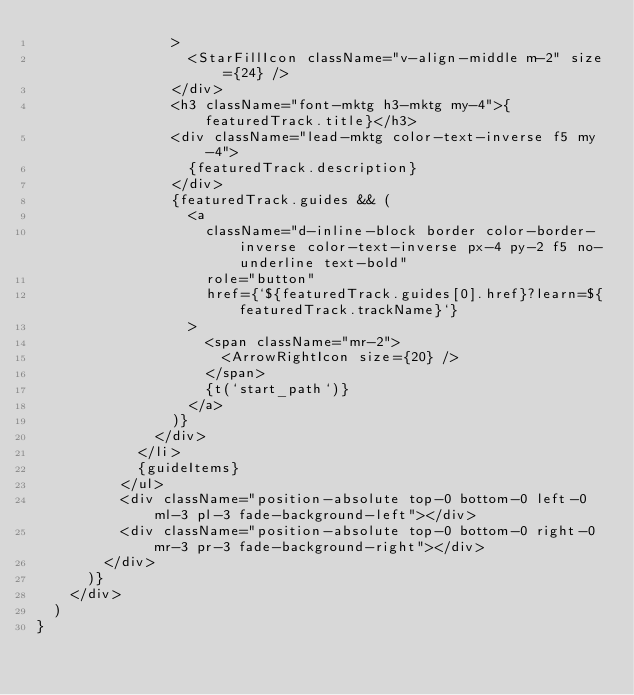<code> <loc_0><loc_0><loc_500><loc_500><_TypeScript_>                >
                  <StarFillIcon className="v-align-middle m-2" size={24} />
                </div>
                <h3 className="font-mktg h3-mktg my-4">{featuredTrack.title}</h3>
                <div className="lead-mktg color-text-inverse f5 my-4">
                  {featuredTrack.description}
                </div>
                {featuredTrack.guides && (
                  <a
                    className="d-inline-block border color-border-inverse color-text-inverse px-4 py-2 f5 no-underline text-bold"
                    role="button"
                    href={`${featuredTrack.guides[0].href}?learn=${featuredTrack.trackName}`}
                  >
                    <span className="mr-2">
                      <ArrowRightIcon size={20} />
                    </span>
                    {t(`start_path`)}
                  </a>
                )}
              </div>
            </li>
            {guideItems}
          </ul>
          <div className="position-absolute top-0 bottom-0 left-0 ml-3 pl-3 fade-background-left"></div>
          <div className="position-absolute top-0 bottom-0 right-0 mr-3 pr-3 fade-background-right"></div>
        </div>
      )}
    </div>
  )
}
</code> 